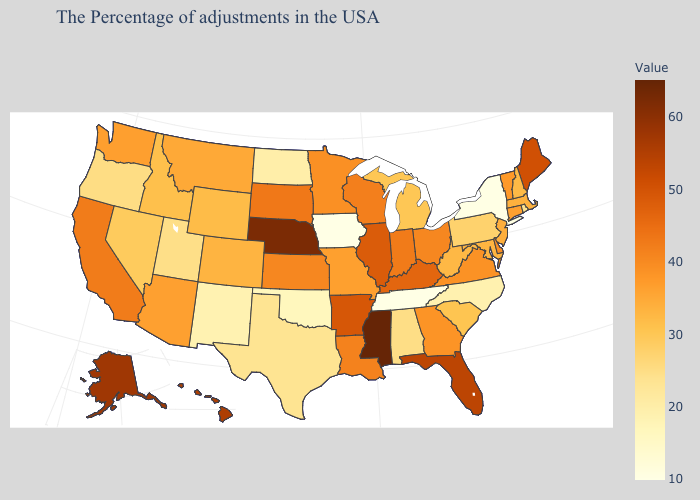Which states have the highest value in the USA?
Answer briefly. Mississippi. Which states have the lowest value in the Northeast?
Short answer required. New York. Does the map have missing data?
Short answer required. No. Does Georgia have a higher value than New Hampshire?
Keep it brief. Yes. 